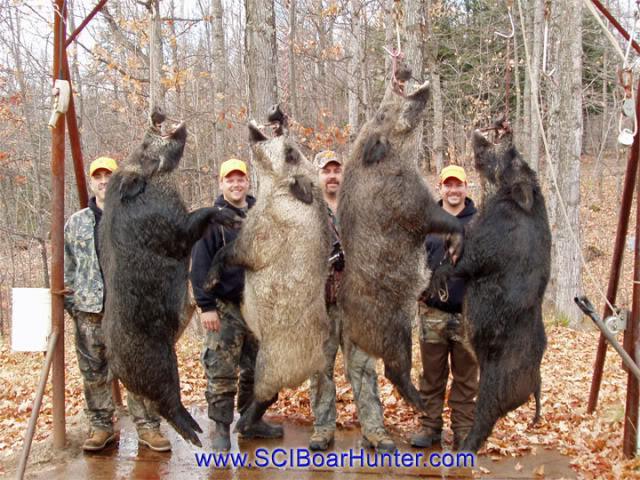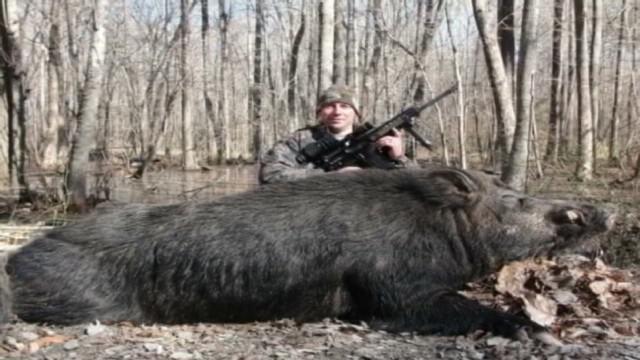The first image is the image on the left, the second image is the image on the right. Given the left and right images, does the statement "A single person is posing with a dead pig in the image on the left." hold true? Answer yes or no. No. The first image is the image on the left, the second image is the image on the right. For the images shown, is this caption "A man with a gun poses behind a downed boar in the right image." true? Answer yes or no. Yes. 